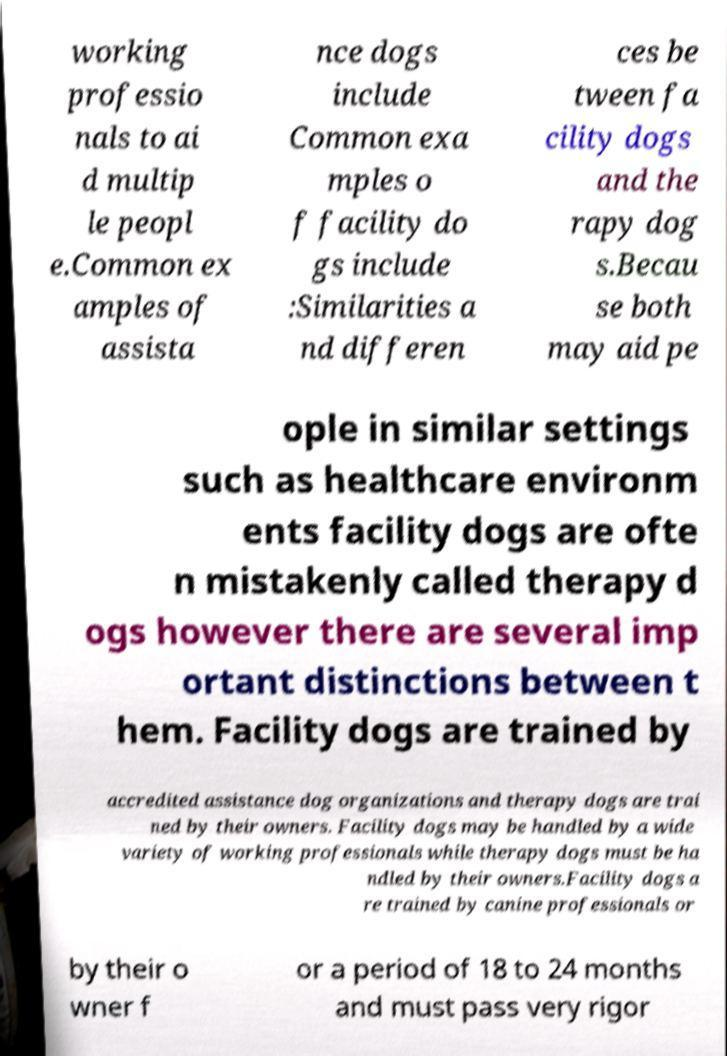I need the written content from this picture converted into text. Can you do that? working professio nals to ai d multip le peopl e.Common ex amples of assista nce dogs include Common exa mples o f facility do gs include :Similarities a nd differen ces be tween fa cility dogs and the rapy dog s.Becau se both may aid pe ople in similar settings such as healthcare environm ents facility dogs are ofte n mistakenly called therapy d ogs however there are several imp ortant distinctions between t hem. Facility dogs are trained by accredited assistance dog organizations and therapy dogs are trai ned by their owners. Facility dogs may be handled by a wide variety of working professionals while therapy dogs must be ha ndled by their owners.Facility dogs a re trained by canine professionals or by their o wner f or a period of 18 to 24 months and must pass very rigor 